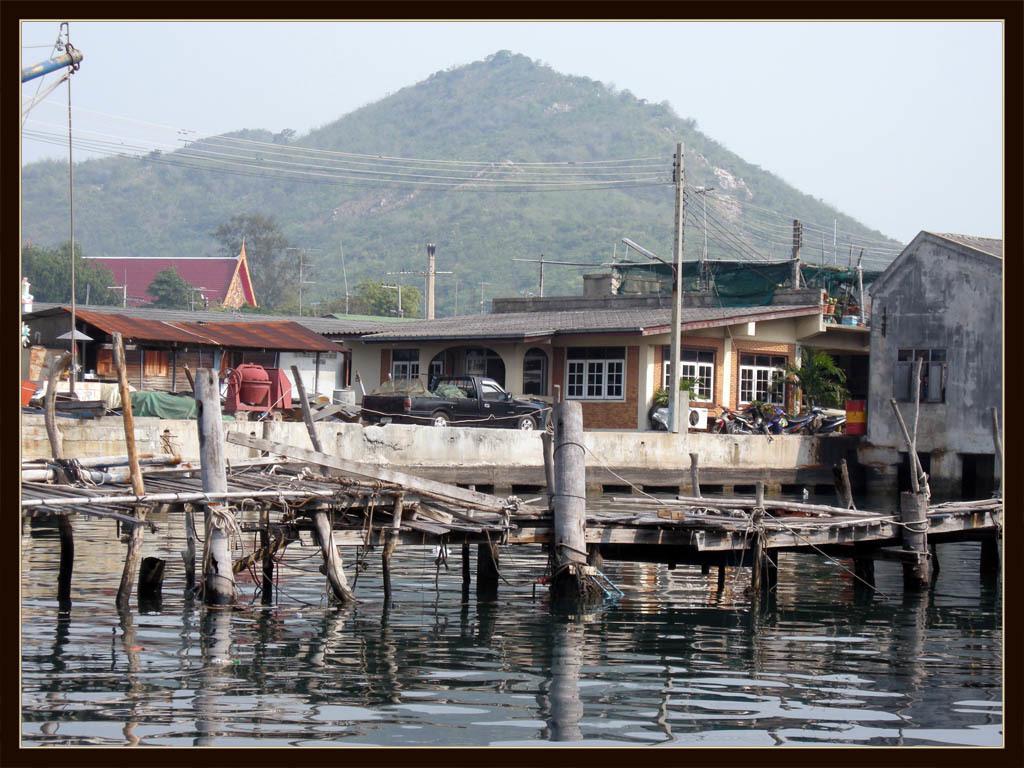Please provide a concise description of this image. In this image I can see a vehicle in black color. I can also see water. Background I can see few buildings in brown, maroon and gray color, I can also see trees in green color and sky in white color. 